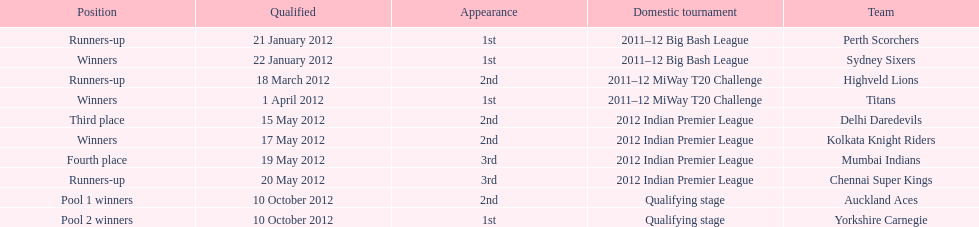What is the total number of teams that qualified? 10. 